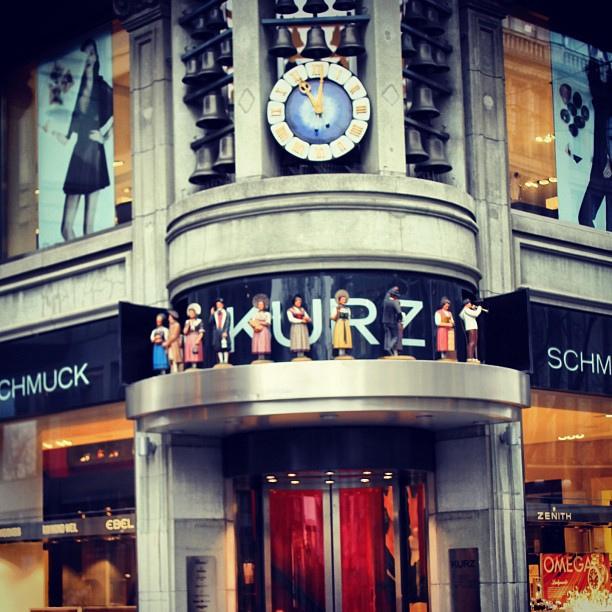What material is the exterior of the building made from?
Concise answer only. Concrete. How many of these figures appear to be men?
Answer briefly. 3. What does the sign on the store read?
Quick response, please. Kurz. 